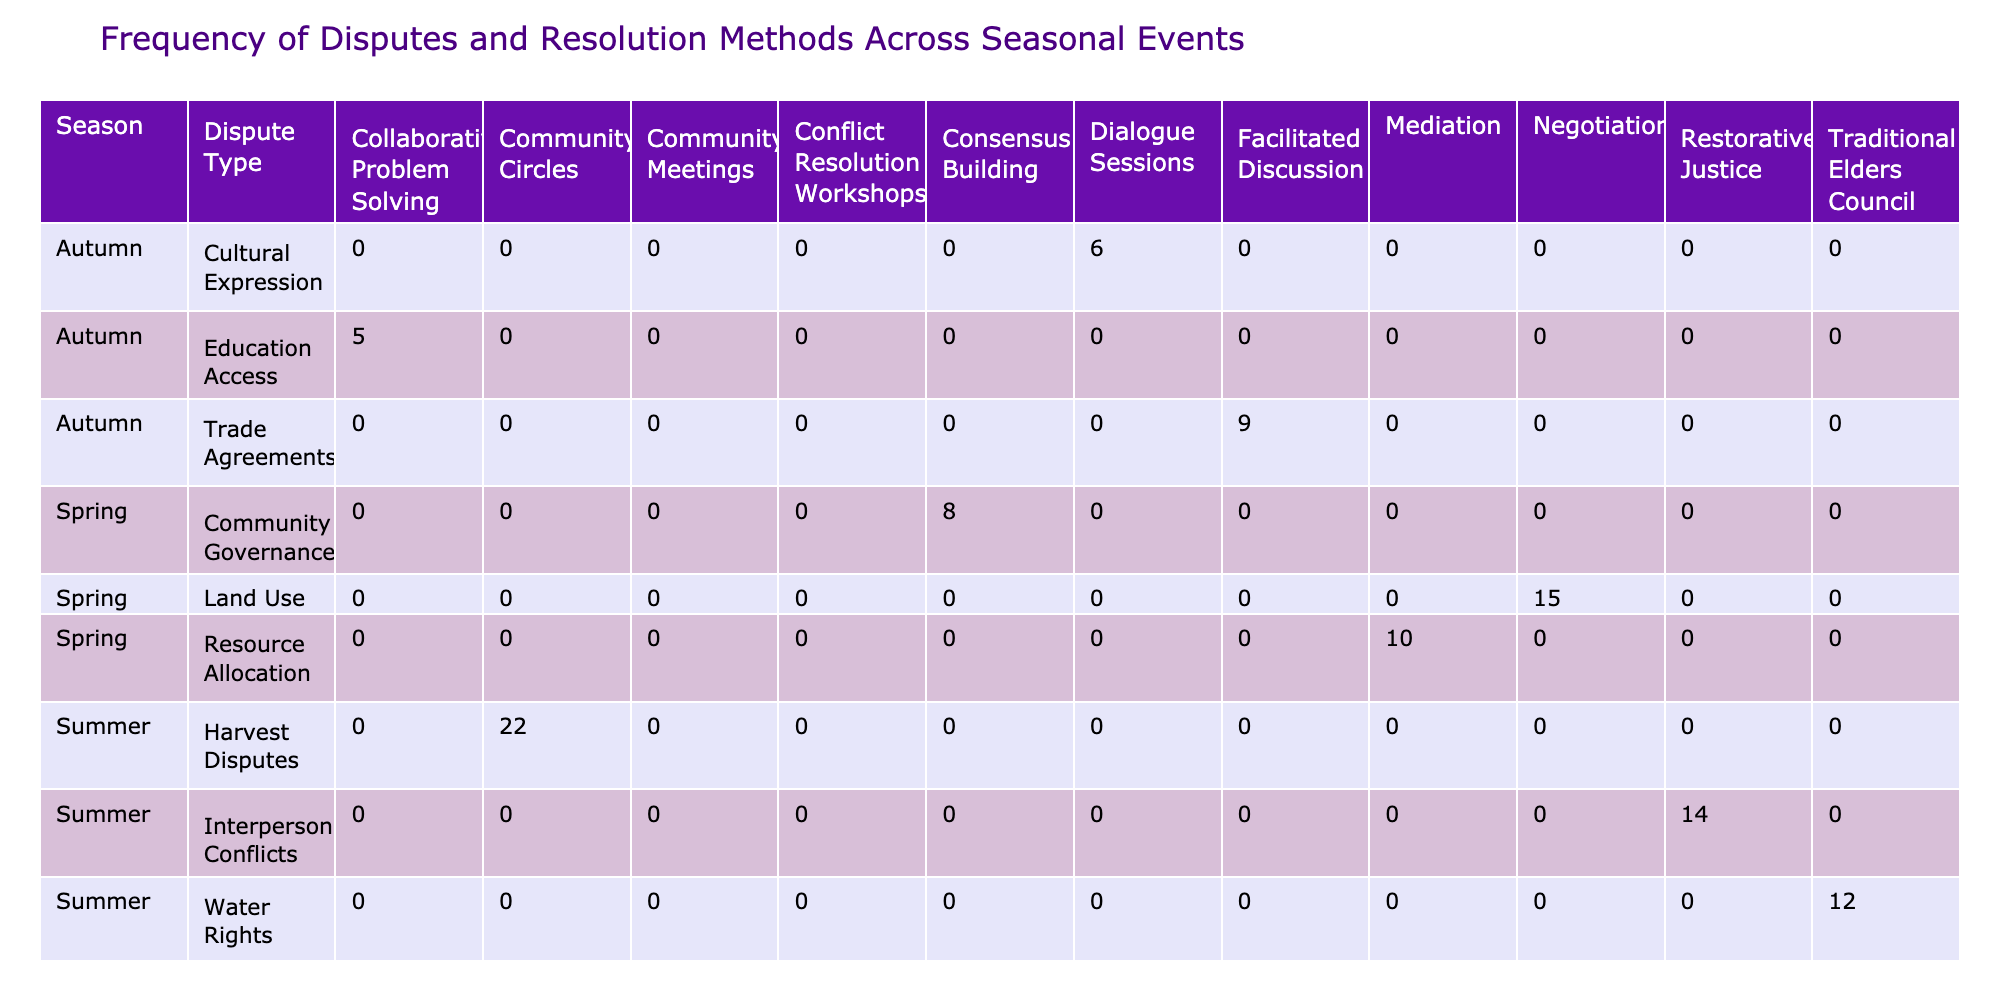What is the frequency of resource allocation disputes in spring? The table shows that the frequency of resource allocation disputes in spring, under the resolution method of mediation, is 10.
Answer: 10 Which resolution method has the highest frequency during summer? By examining the summer row, we see that harvest disputes use the community circles resolution method, which has the highest frequency at 22.
Answer: 22 What is the total frequency of disputes resolved through negotiation across all seasons? Negotiation occurs in spring (15), winter (13), and yields a total of 15 + 13 = 28 through sum aggregation.
Answer: 28 Is the frequency of disputes higher in autumn compared to winter? In autumn, the total frequencies are 6 + 9 + 5 = 20, while in winter the total frequencies are 11 + 7 + 13 = 31, leading us to conclude that winter has a higher frequency of disputes.
Answer: No What is the average frequency of resolutions through dialogue sessions across all seasons? In the table, dialogue sessions occur only in autumn with a frequency of 6. Since there’s only one entry, the average is simply 6/1 = 6.
Answer: 6 How many disputes require a consensus building resolution in spring? Looking at spring, consensus building resolves community governance disputes, with a frequency of 8.
Answer: 8 Which season features the least frequency of disputes, and what is that frequency? The autumn season has the lowest total dispute frequency at 20, which is calculated by summing 6, 9, and 5 from all its dispute types.
Answer: 20 How many more disputes are resolved through community circles in summer than through conflict resolution workshops in winter? Community circles in summer have a frequency of 22 while conflict resolution workshops in winter have a frequency of 11. The difference is 22 - 11 = 11.
Answer: 11 Is restorative justice used more frequently in summer than consensus building in spring? Restorative justice has a frequency of 14 in summer, while consensus building has 8 in spring, showing that restorative justice is indeed used more frequently.
Answer: Yes 